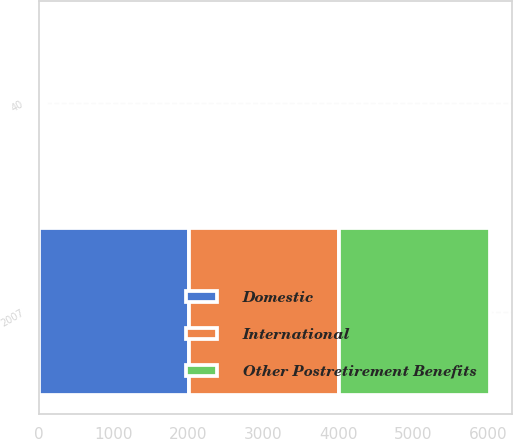Convert chart. <chart><loc_0><loc_0><loc_500><loc_500><stacked_bar_chart><ecel><fcel>2007<fcel>40<nl><fcel>International<fcel>2006<fcel>37<nl><fcel>Other Postretirement Benefits<fcel>2007<fcel>27<nl><fcel>Domestic<fcel>2007<fcel>35<nl></chart> 